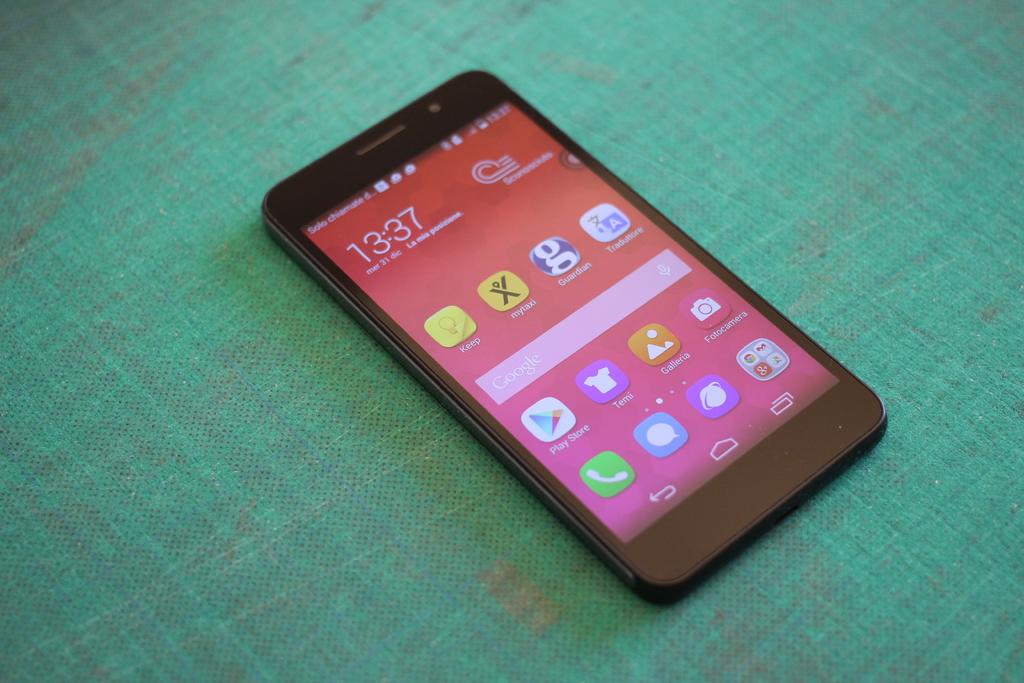What's the time on the phone?
Your answer should be compact. 13:37. 